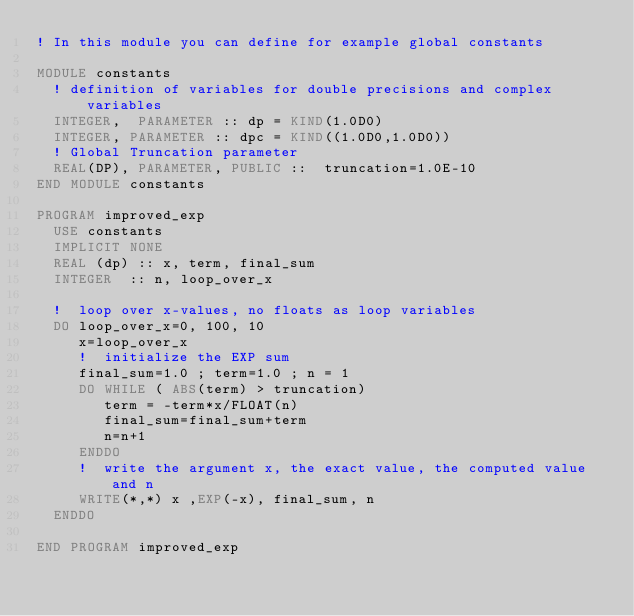Convert code to text. <code><loc_0><loc_0><loc_500><loc_500><_FORTRAN_>! In this module you can define for example global constants

MODULE constants
  ! definition of variables for double precisions and complex variables 
  INTEGER,  PARAMETER :: dp = KIND(1.0D0)
  INTEGER, PARAMETER :: dpc = KIND((1.0D0,1.0D0))
  ! Global Truncation parameter
  REAL(DP), PARAMETER, PUBLIC ::  truncation=1.0E-10
END MODULE constants

PROGRAM improved_exp
  USE constants
  IMPLICIT NONE  
  REAL (dp) :: x, term, final_sum
  INTEGER  :: n, loop_over_x

  !  loop over x-values, no floats as loop variables
  DO loop_over_x=0, 100, 10
     x=loop_over_x
     !  initialize the EXP sum
     final_sum=1.0 ; term=1.0 ; n = 1
     DO WHILE ( ABS(term) > truncation)
        term = -term*x/FLOAT(n)
        final_sum=final_sum+term
        n=n+1
     ENDDO
     !  write the argument x, the exact value, the computed value and n
     WRITE(*,*) x ,EXP(-x), final_sum, n
  ENDDO

END PROGRAM improved_exp
</code> 